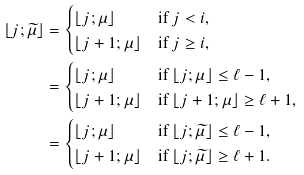<formula> <loc_0><loc_0><loc_500><loc_500>\lfloor j ; \widetilde { \mu } \rfloor & = \begin{cases} \lfloor j ; \mu \rfloor & \text {if $j<i$,} \\ \lfloor j + 1 ; \mu \rfloor & \text {if $j\geq i$,} \end{cases} \\ & = \begin{cases} \lfloor j ; \mu \rfloor & \text {if $\lfloor j;\mu\rfloor\leq\ell-1$,} \\ \lfloor j + 1 ; \mu \rfloor & \text {if $\lfloor j+1;\mu\rfloor\geq\ell+1$,} \end{cases} \\ & = \begin{cases} \lfloor j ; \mu \rfloor & \text {if $\lfloor j;\widetilde{\mu}\rfloor\leq\ell-1$,} \\ \lfloor j + 1 ; \mu \rfloor & \text {if $\lfloor j;\widetilde{\mu}\rfloor\geq\ell+1$.} \end{cases}</formula> 